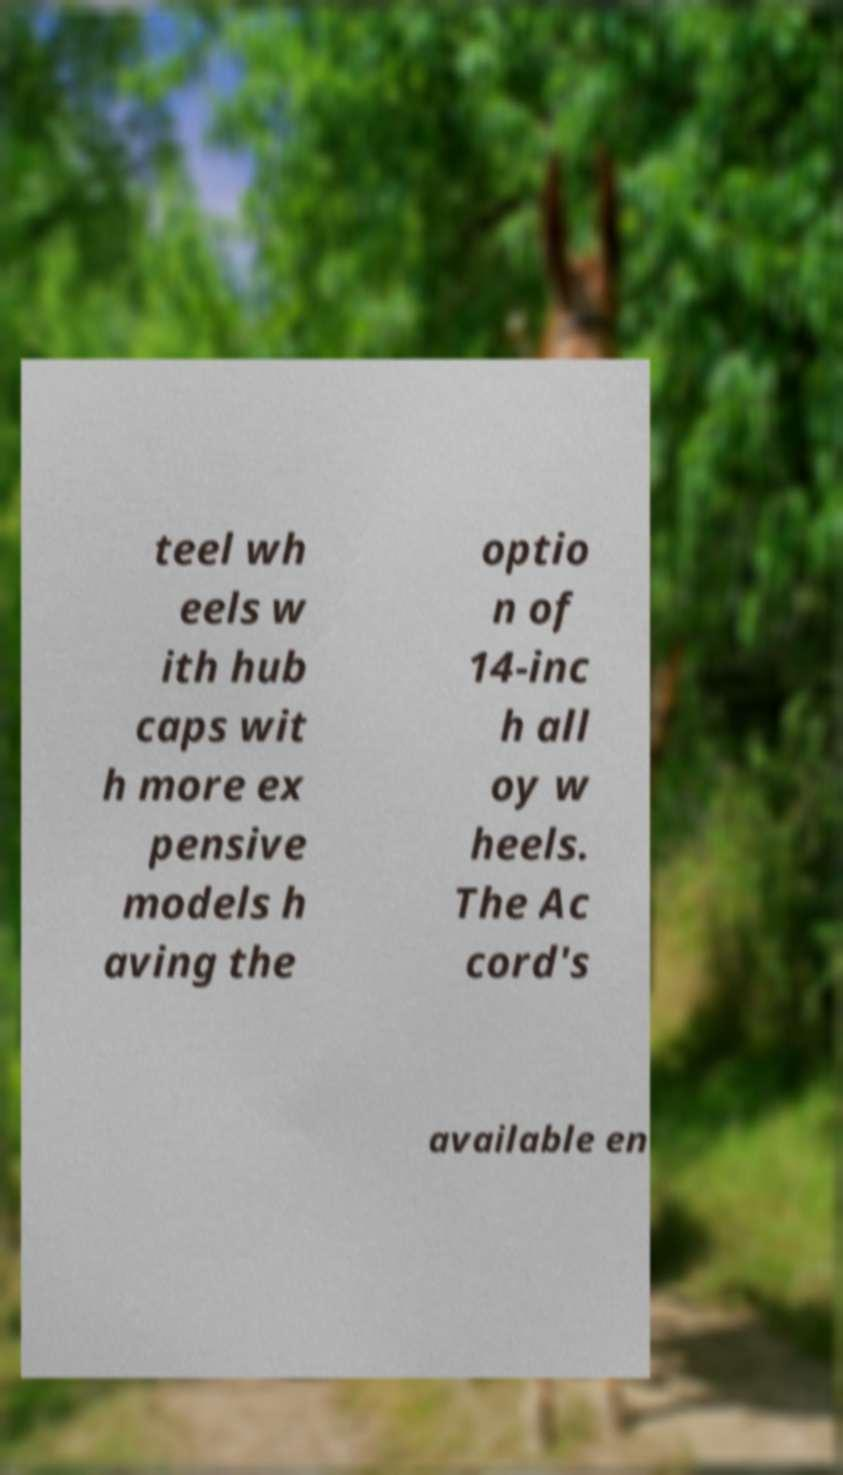For documentation purposes, I need the text within this image transcribed. Could you provide that? teel wh eels w ith hub caps wit h more ex pensive models h aving the optio n of 14-inc h all oy w heels. The Ac cord's available en 